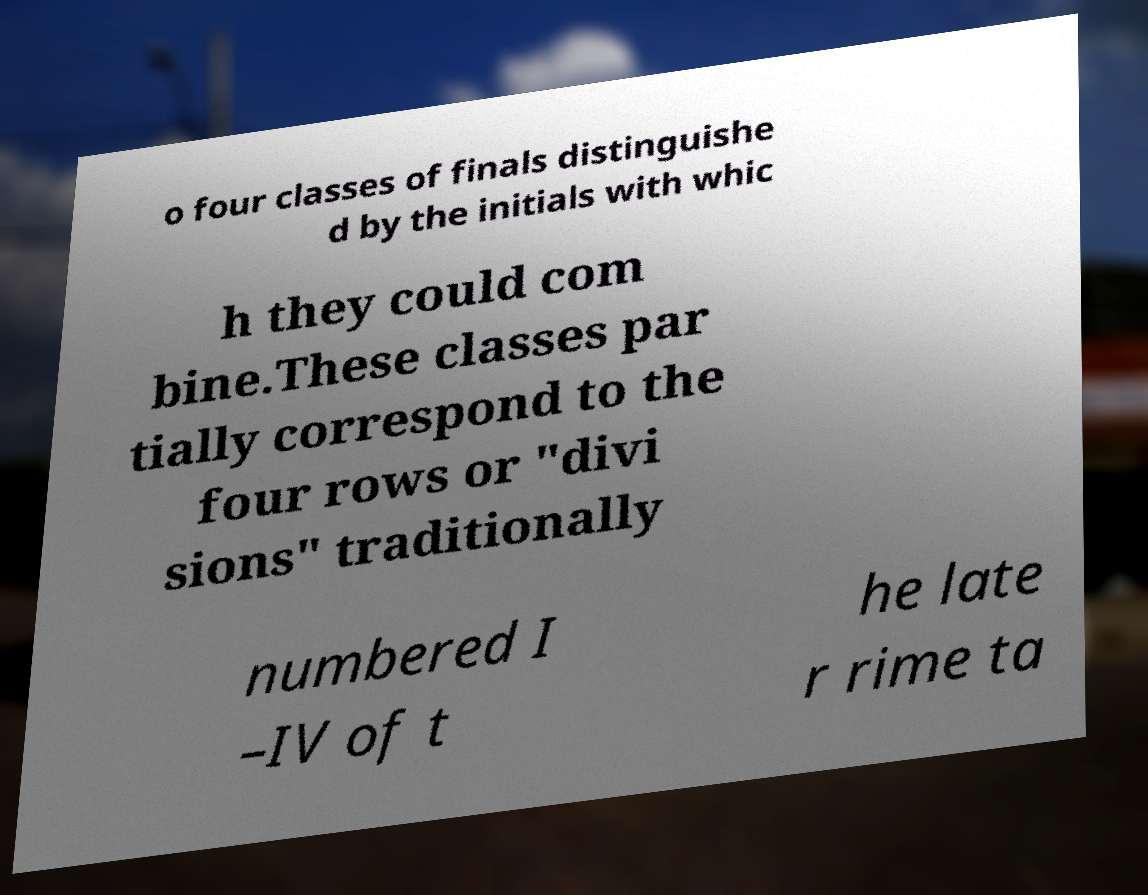What messages or text are displayed in this image? I need them in a readable, typed format. o four classes of finals distinguishe d by the initials with whic h they could com bine.These classes par tially correspond to the four rows or "divi sions" traditionally numbered I –IV of t he late r rime ta 